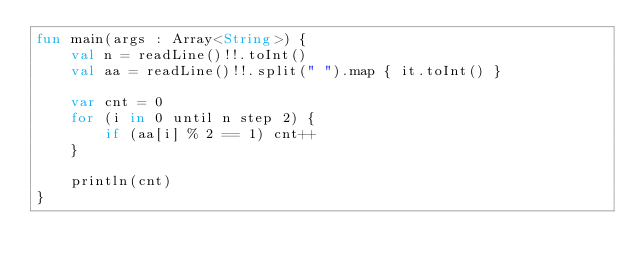<code> <loc_0><loc_0><loc_500><loc_500><_Kotlin_>fun main(args : Array<String>) {
    val n = readLine()!!.toInt()
    val aa = readLine()!!.split(" ").map { it.toInt() }

    var cnt = 0
    for (i in 0 until n step 2) {
        if (aa[i] % 2 == 1) cnt++
    }

    println(cnt)
}</code> 